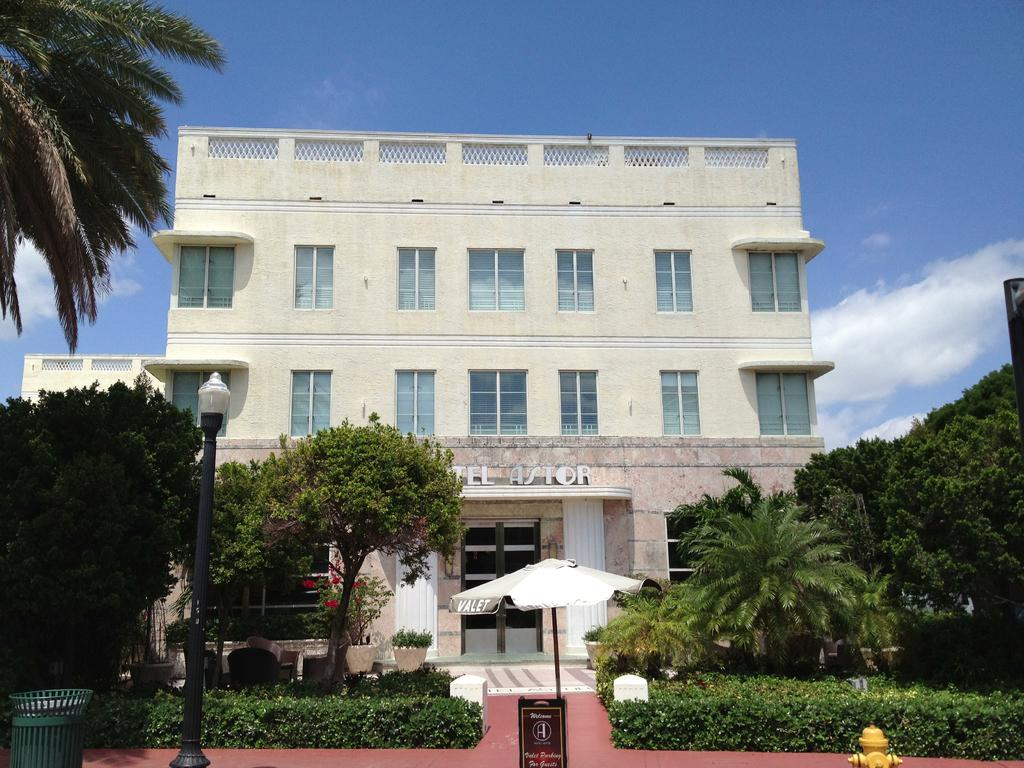<image>
Write a terse but informative summary of the picture. the word astor is at the top of a building 